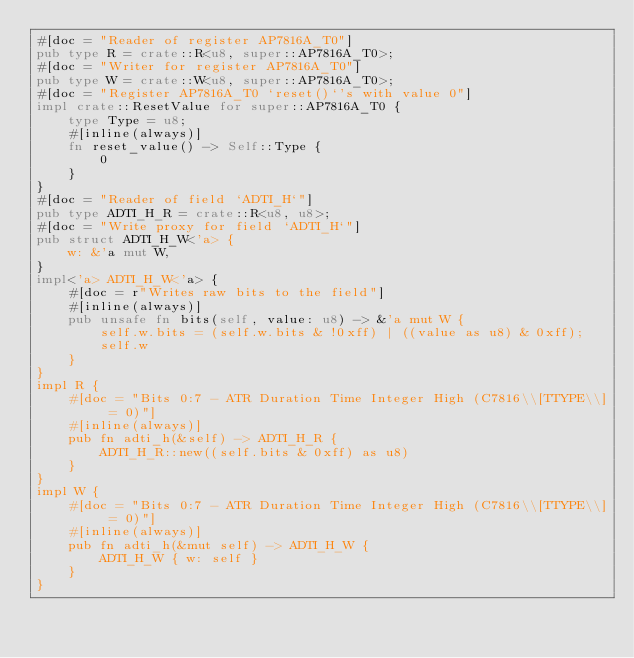Convert code to text. <code><loc_0><loc_0><loc_500><loc_500><_Rust_>#[doc = "Reader of register AP7816A_T0"]
pub type R = crate::R<u8, super::AP7816A_T0>;
#[doc = "Writer for register AP7816A_T0"]
pub type W = crate::W<u8, super::AP7816A_T0>;
#[doc = "Register AP7816A_T0 `reset()`'s with value 0"]
impl crate::ResetValue for super::AP7816A_T0 {
    type Type = u8;
    #[inline(always)]
    fn reset_value() -> Self::Type {
        0
    }
}
#[doc = "Reader of field `ADTI_H`"]
pub type ADTI_H_R = crate::R<u8, u8>;
#[doc = "Write proxy for field `ADTI_H`"]
pub struct ADTI_H_W<'a> {
    w: &'a mut W,
}
impl<'a> ADTI_H_W<'a> {
    #[doc = r"Writes raw bits to the field"]
    #[inline(always)]
    pub unsafe fn bits(self, value: u8) -> &'a mut W {
        self.w.bits = (self.w.bits & !0xff) | ((value as u8) & 0xff);
        self.w
    }
}
impl R {
    #[doc = "Bits 0:7 - ATR Duration Time Integer High (C7816\\[TTYPE\\] = 0)"]
    #[inline(always)]
    pub fn adti_h(&self) -> ADTI_H_R {
        ADTI_H_R::new((self.bits & 0xff) as u8)
    }
}
impl W {
    #[doc = "Bits 0:7 - ATR Duration Time Integer High (C7816\\[TTYPE\\] = 0)"]
    #[inline(always)]
    pub fn adti_h(&mut self) -> ADTI_H_W {
        ADTI_H_W { w: self }
    }
}
</code> 